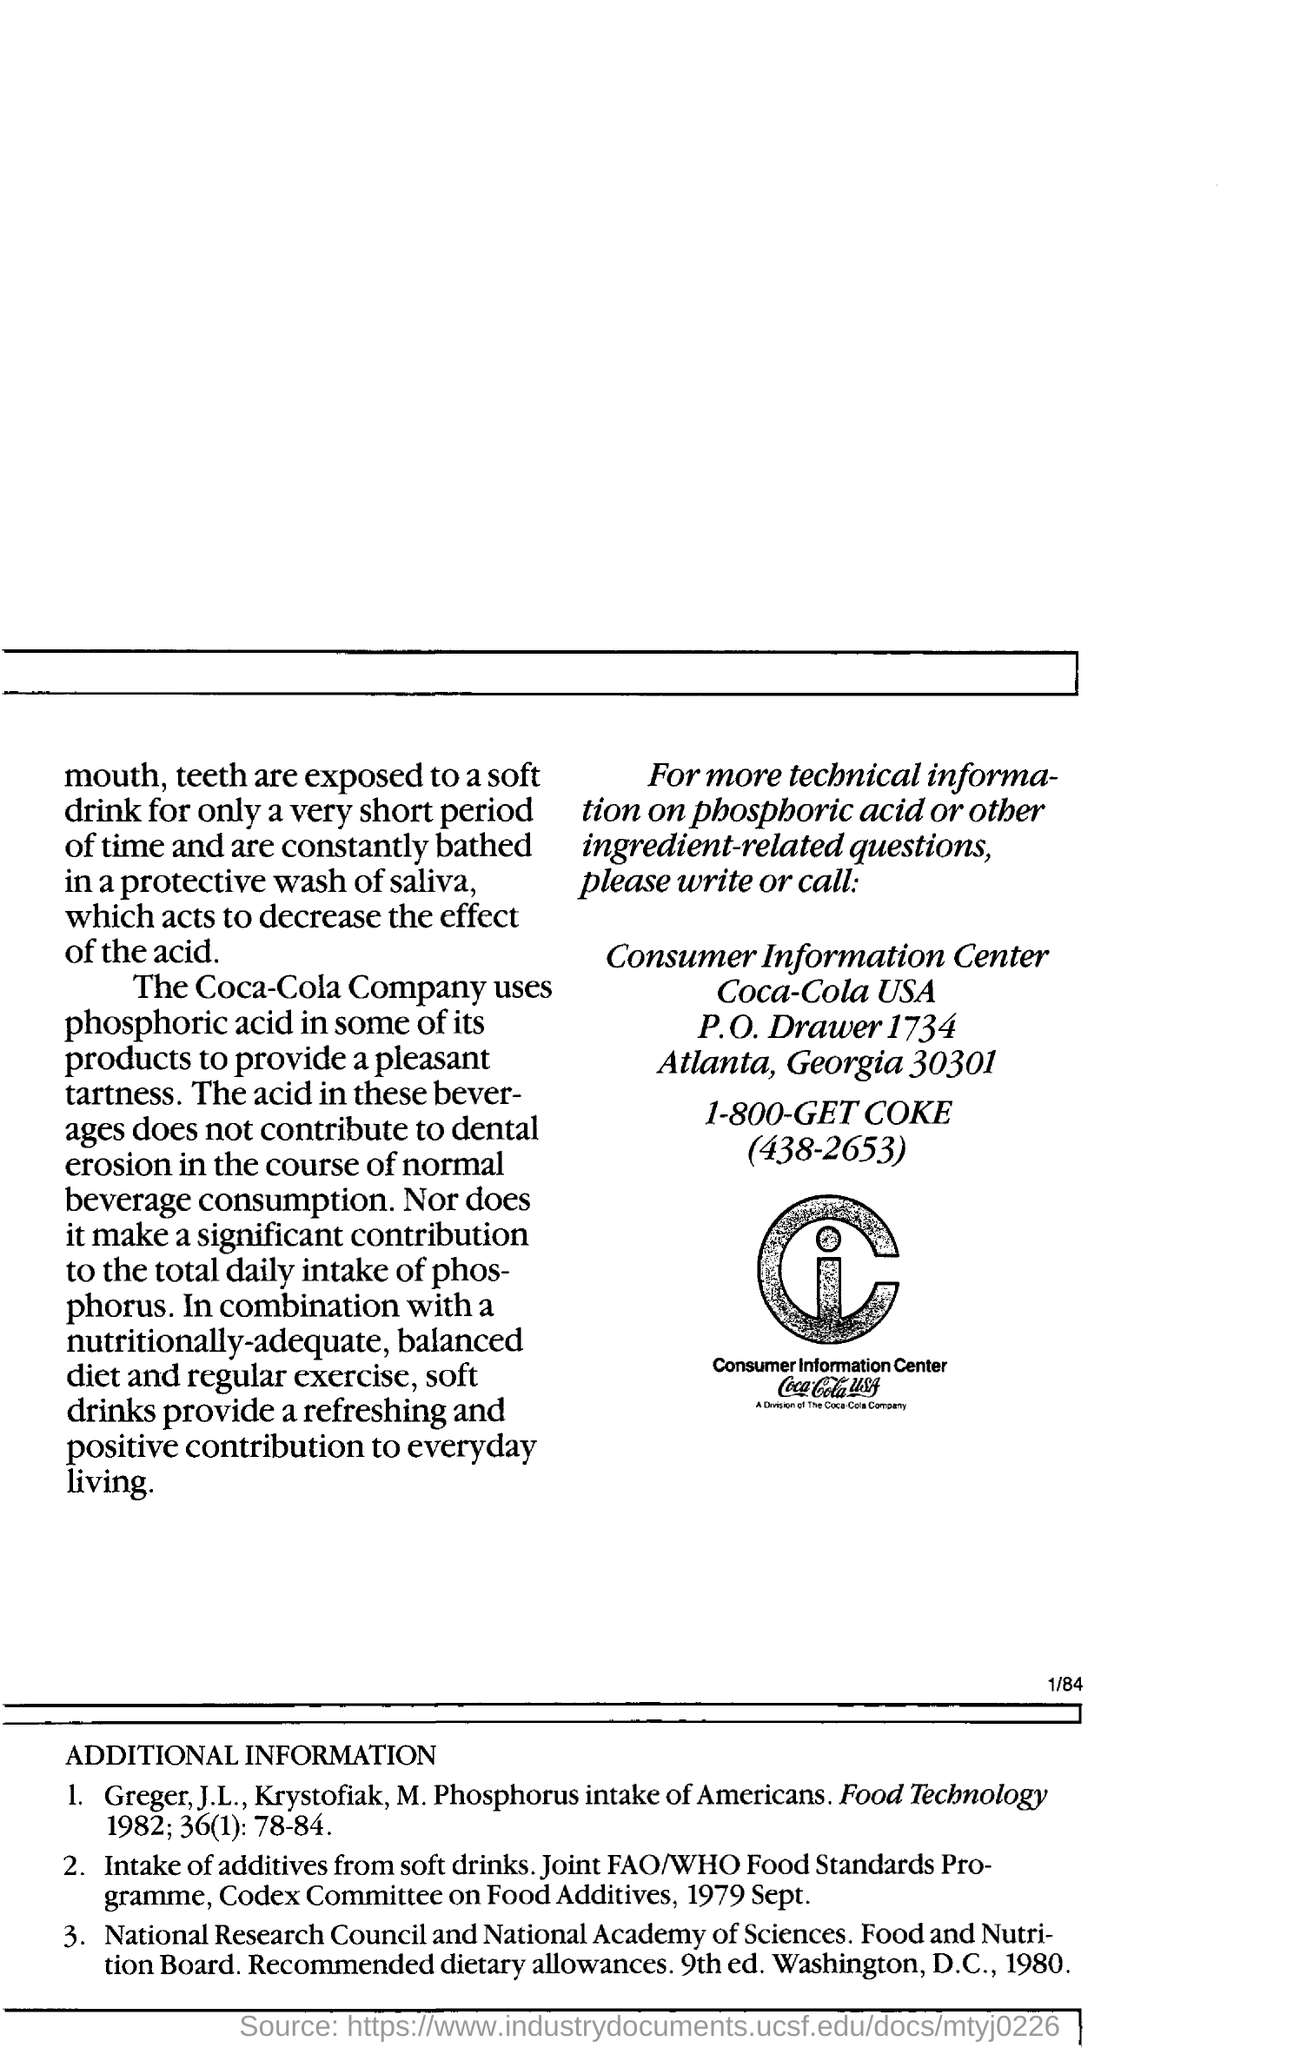In which country is the consumer information centre located?
Provide a short and direct response. Atlanta, Georgia 30301. Which acid do the coca-cola company use to provide a pleasant tartness?
Give a very brief answer. Phosphoric acid. What does soft drinks provide ?
Give a very brief answer. Refreshing and positive contribution to everyday living. 